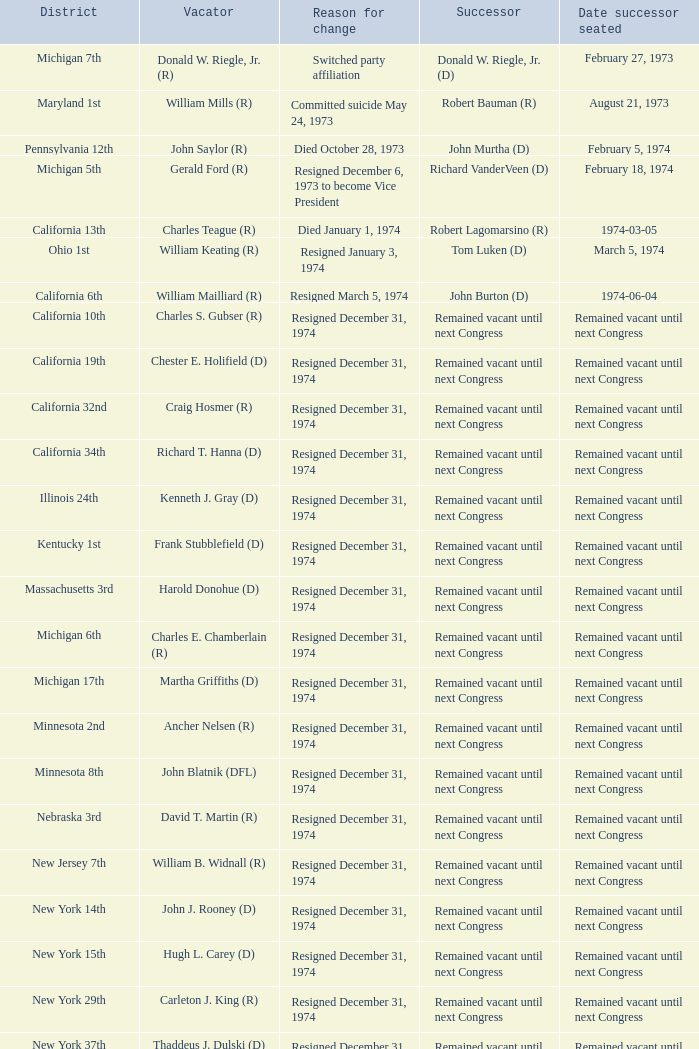Give me the full table as a dictionary. {'header': ['District', 'Vacator', 'Reason for change', 'Successor', 'Date successor seated'], 'rows': [['Michigan 7th', 'Donald W. Riegle, Jr. (R)', 'Switched party affiliation', 'Donald W. Riegle, Jr. (D)', 'February 27, 1973'], ['Maryland 1st', 'William Mills (R)', 'Committed suicide May 24, 1973', 'Robert Bauman (R)', 'August 21, 1973'], ['Pennsylvania 12th', 'John Saylor (R)', 'Died October 28, 1973', 'John Murtha (D)', 'February 5, 1974'], ['Michigan 5th', 'Gerald Ford (R)', 'Resigned December 6, 1973 to become Vice President', 'Richard VanderVeen (D)', 'February 18, 1974'], ['California 13th', 'Charles Teague (R)', 'Died January 1, 1974', 'Robert Lagomarsino (R)', '1974-03-05'], ['Ohio 1st', 'William Keating (R)', 'Resigned January 3, 1974', 'Tom Luken (D)', 'March 5, 1974'], ['California 6th', 'William Mailliard (R)', 'Resigned March 5, 1974', 'John Burton (D)', '1974-06-04'], ['California 10th', 'Charles S. Gubser (R)', 'Resigned December 31, 1974', 'Remained vacant until next Congress', 'Remained vacant until next Congress'], ['California 19th', 'Chester E. Holifield (D)', 'Resigned December 31, 1974', 'Remained vacant until next Congress', 'Remained vacant until next Congress'], ['California 32nd', 'Craig Hosmer (R)', 'Resigned December 31, 1974', 'Remained vacant until next Congress', 'Remained vacant until next Congress'], ['California 34th', 'Richard T. Hanna (D)', 'Resigned December 31, 1974', 'Remained vacant until next Congress', 'Remained vacant until next Congress'], ['Illinois 24th', 'Kenneth J. Gray (D)', 'Resigned December 31, 1974', 'Remained vacant until next Congress', 'Remained vacant until next Congress'], ['Kentucky 1st', 'Frank Stubblefield (D)', 'Resigned December 31, 1974', 'Remained vacant until next Congress', 'Remained vacant until next Congress'], ['Massachusetts 3rd', 'Harold Donohue (D)', 'Resigned December 31, 1974', 'Remained vacant until next Congress', 'Remained vacant until next Congress'], ['Michigan 6th', 'Charles E. Chamberlain (R)', 'Resigned December 31, 1974', 'Remained vacant until next Congress', 'Remained vacant until next Congress'], ['Michigan 17th', 'Martha Griffiths (D)', 'Resigned December 31, 1974', 'Remained vacant until next Congress', 'Remained vacant until next Congress'], ['Minnesota 2nd', 'Ancher Nelsen (R)', 'Resigned December 31, 1974', 'Remained vacant until next Congress', 'Remained vacant until next Congress'], ['Minnesota 8th', 'John Blatnik (DFL)', 'Resigned December 31, 1974', 'Remained vacant until next Congress', 'Remained vacant until next Congress'], ['Nebraska 3rd', 'David T. Martin (R)', 'Resigned December 31, 1974', 'Remained vacant until next Congress', 'Remained vacant until next Congress'], ['New Jersey 7th', 'William B. Widnall (R)', 'Resigned December 31, 1974', 'Remained vacant until next Congress', 'Remained vacant until next Congress'], ['New York 14th', 'John J. Rooney (D)', 'Resigned December 31, 1974', 'Remained vacant until next Congress', 'Remained vacant until next Congress'], ['New York 15th', 'Hugh L. Carey (D)', 'Resigned December 31, 1974', 'Remained vacant until next Congress', 'Remained vacant until next Congress'], ['New York 29th', 'Carleton J. King (R)', 'Resigned December 31, 1974', 'Remained vacant until next Congress', 'Remained vacant until next Congress'], ['New York 37th', 'Thaddeus J. Dulski (D)', 'Resigned December 31, 1974', 'Remained vacant until next Congress', 'Remained vacant until next Congress'], ['Ohio 23rd', 'William Minshall (R)', 'Resigned December 31, 1974', 'Remained vacant until next Congress', 'Remained vacant until next Congress'], ['Oregon 3rd', 'Edith S. Green (D)', 'Resigned December 31, 1974', 'Remained vacant until next Congress', 'Remained vacant until next Congress'], ['Pennsylvania 25th', 'Frank M. Clark (D)', 'Resigned December 31, 1974', 'Remained vacant until next Congress', 'Remained vacant until next Congress'], ['South Carolina 3rd', 'W.J. Bryan Dorn (D)', 'Resigned December 31, 1974', 'Remained vacant until next Congress', 'Remained vacant until next Congress'], ['South Carolina 5th', 'Thomas S. Gettys (D)', 'Resigned December 31, 1974', 'Remained vacant until next Congress', 'Remained vacant until next Congress'], ['Texas 21st', 'O. C. Fisher (D)', 'Resigned December 31, 1974', 'Remained vacant until next Congress', 'Remained vacant until next Congress'], ['Washington 3rd', 'Julia B. Hansen (D)', 'Resigned December 31, 1974', 'Remained vacant until next Congress', 'Remained vacant until next Congress'], ['Wisconsin 3rd', 'Vernon W. Thomson (R)', 'Resigned December 31, 1974', 'Remained vacant until next Congress', 'Remained vacant until next Congress']]} When was the successor seated when the district was California 10th? Remained vacant until next Congress. 